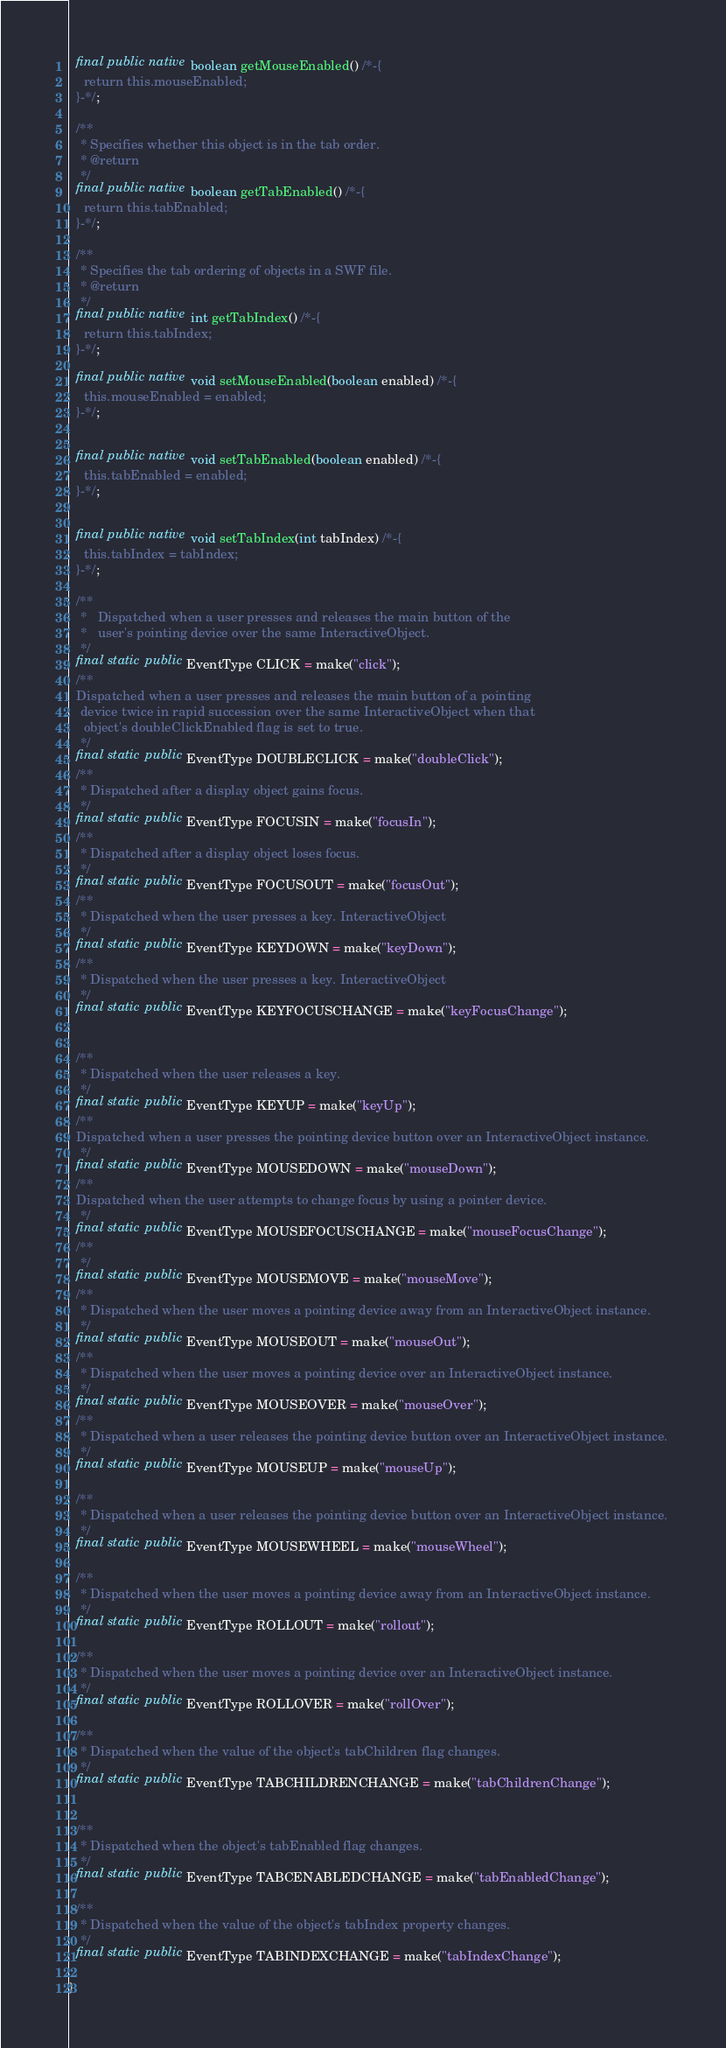Convert code to text. <code><loc_0><loc_0><loc_500><loc_500><_Java_>  final public native boolean getMouseEnabled() /*-{
    return this.mouseEnabled;
  }-*/;

  /**
   * Specifies whether this object is in the tab order.
   * @return
   */
  final public native boolean getTabEnabled() /*-{
    return this.tabEnabled;
  }-*/;

  /**
   * Specifies the tab ordering of objects in a SWF file.
   * @return
   */
  final public native int getTabIndex() /*-{
    return this.tabIndex;
  }-*/;

  final public native void setMouseEnabled(boolean enabled) /*-{
    this.mouseEnabled = enabled;
  }-*/;


  final public native void setTabEnabled(boolean enabled) /*-{
    this.tabEnabled = enabled;
  }-*/;


  final public native void setTabIndex(int tabIndex) /*-{
    this.tabIndex = tabIndex;
  }-*/;

  /**
   *   Dispatched when a user presses and releases the main button of the 
   *   user's pointing device over the same InteractiveObject. 
   */
  final static public EventType CLICK = make("click");
  /**
  Dispatched when a user presses and releases the main button of a pointing
   device twice in rapid succession over the same InteractiveObject when that
    object's doubleClickEnabled flag is set to true. 
   */
  final static public EventType DOUBLECLICK = make("doubleClick");
  /**
   * Dispatched after a display object gains focus. 
   */
  final static public EventType FOCUSIN = make("focusIn");
  /**
   * Dispatched after a display object loses focus.  
   */
  final static public EventType FOCUSOUT = make("focusOut");
  /**
   * Dispatched when the user presses a key. InteractiveObject
   */
  final static public EventType KEYDOWN = make("keyDown");
  /**
   * Dispatched when the user presses a key. InteractiveObject
   */
  final static public EventType KEYFOCUSCHANGE = make("keyFocusChange");


  /**
   * Dispatched when the user releases a key.    
   */
  final static public EventType KEYUP = make("keyUp");
  /**
  Dispatched when a user presses the pointing device button over an InteractiveObject instance.   
   */
  final static public EventType MOUSEDOWN = make("mouseDown");
  /**
  Dispatched when the user attempts to change focus by using a pointer device.    
   */
  final static public EventType MOUSEFOCUSCHANGE = make("mouseFocusChange");
  /**
   */
  final static public EventType MOUSEMOVE = make("mouseMove");
  /**
   * Dispatched when the user moves a pointing device away from an InteractiveObject instance.   
   */
  final static public EventType MOUSEOUT = make("mouseOut");
  /**
   * Dispatched when the user moves a pointing device over an InteractiveObject instance.   
   */
  final static public EventType MOUSEOVER = make("mouseOver");
  /**
   * Dispatched when a user releases the pointing device button over an InteractiveObject instance. 
   */
  final static public EventType MOUSEUP = make("mouseUp");

  /**
   * Dispatched when a user releases the pointing device button over an InteractiveObject instance. 
   */
  final static public EventType MOUSEWHEEL = make("mouseWheel");

  /**
   * Dispatched when the user moves a pointing device away from an InteractiveObject instance.  
   */
  final static public EventType ROLLOUT = make("rollout");

  /**
   * Dispatched when the user moves a pointing device over an InteractiveObject instance.
   */
  final static public EventType ROLLOVER = make("rollOver");

  /**
   * Dispatched when the value of the object's tabChildren flag changes. 
   */
  final static public EventType TABCHILDRENCHANGE = make("tabChildrenChange");


  /**
   * Dispatched when the object's tabEnabled flag changes.  
   */
  final static public EventType TABCENABLEDCHANGE = make("tabEnabledChange");
  
  /**
   * Dispatched when the value of the object's tabIndex property changes.
   */
  final static public EventType TABINDEXCHANGE = make("tabIndexChange");

}
</code> 